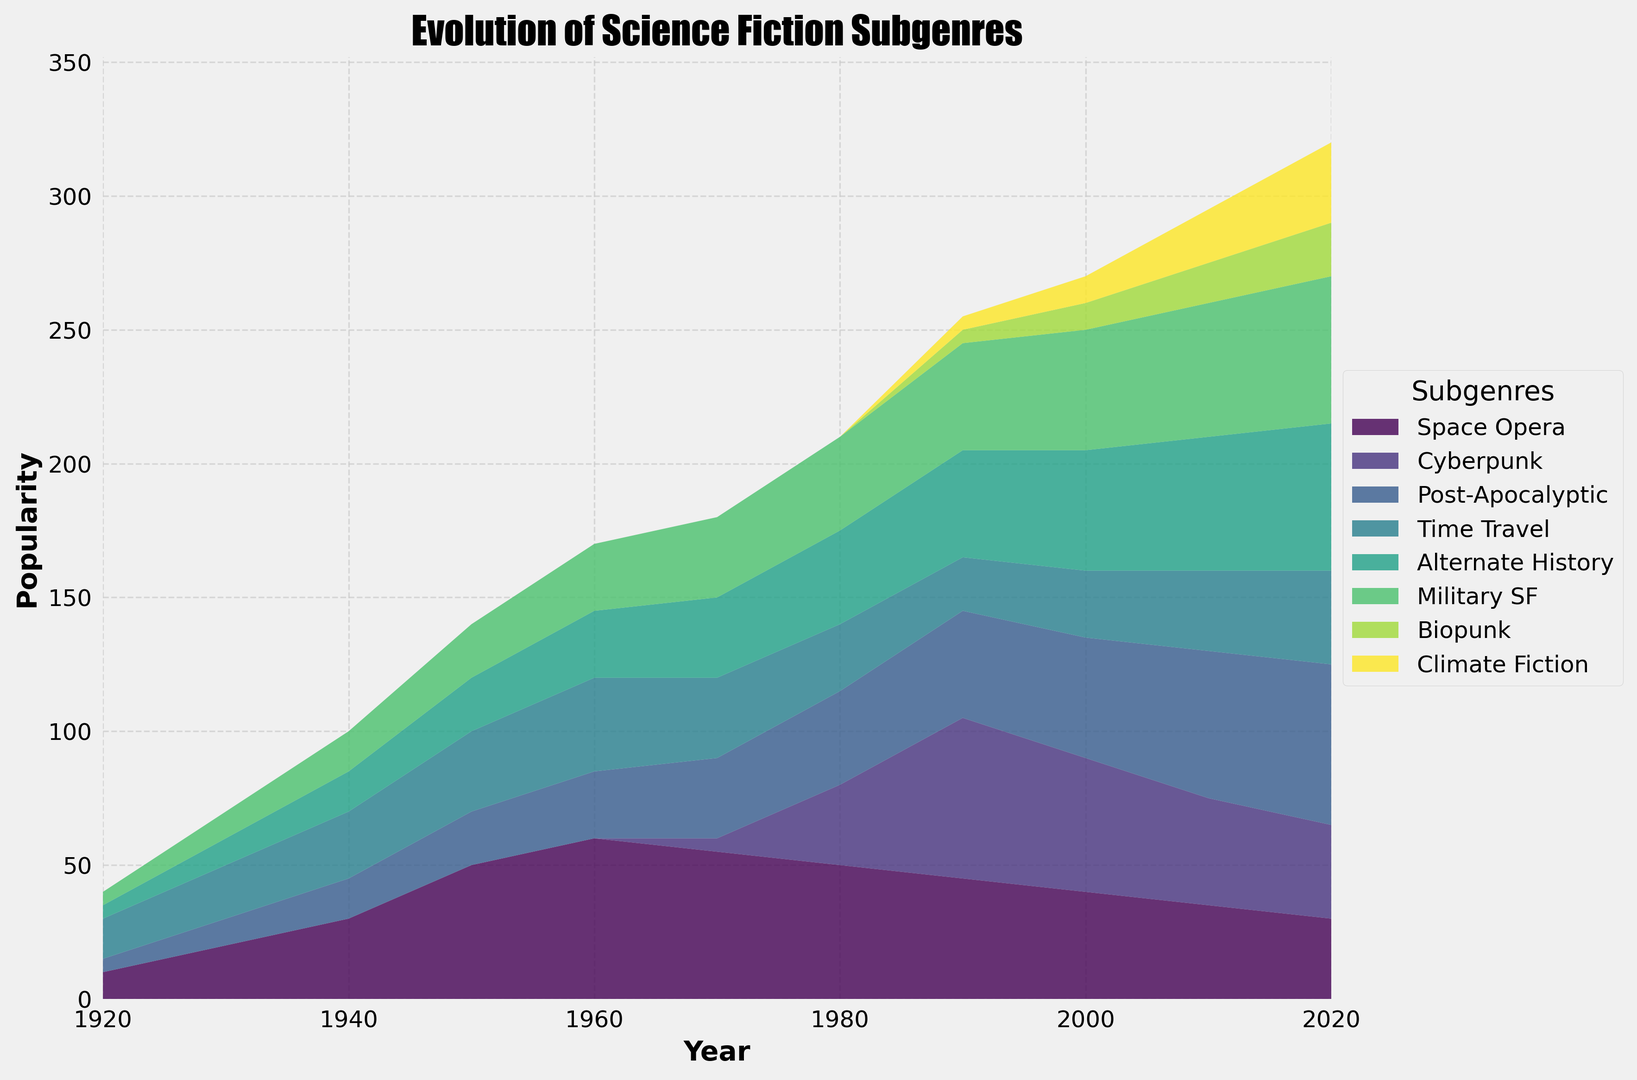What subgenre had its peak popularity in the 1980s? By examining the chart, we can observe that 'Cyberpunk' has a significant peak in 1980, with other subgenres maintaining steady or lower levels in comparison.
Answer: Cyberpunk Which subgenre showed the most consistent growth from 1920 to 2020? Looking at the subgenres, 'Alternate History' shows a steady and consistent increase across the century without any major dips.
Answer: Alternate History Compare the popularity trends of 'Space Opera' and 'Post-Apocalyptic' in 1960. Which one was more popular, and by how much? In 1960, 'Space Opera' has a value of 60, while 'Post-Apocalyptic' has a value of 25. Therefore, 'Space Opera' was more popular by 35.
Answer: Space Opera by 35 Which subgenres show a decline in popularity from 1980 to 2020? Observing the chart, 'Space Opera' and 'Cyberpunk' both show a decline in popularity from 1980 to 2020.
Answer: Space Opera, Cyberpunk What is the combined popularity of 'Biopunk' and 'Climate Fiction' in 2020? In 2020, 'Biopunk' has a value of 20, and 'Climate Fiction' has a value of 30. Their combined popularity is 20 + 30 = 50.
Answer: 50 Which subgenre had its highest relative growth between two consecutive decades? The interest in 'Cyberpunk' shows the highest relative growth, from 0 in the 1970s to 30 in the 1980s, marking a significant leap.
Answer: Cyberpunk What is the average popularity of 'Time Travel' over the 100 years? To find the average: sum up the popularity values for 'Time Travel' and divide by the number of years: (15 + 20 + 25 + 30 + 35 + 30 + 25 + 20 + 25 + 30 + 35) / 11 = 30.
Answer: 30 Which subgenre had exactly zero popularity in the 1920s? From the chart, 'Cyberpunk' and 'Biopunk' both had zero popularity in the 1920s.
Answer: Cyberpunk, Biopunk 